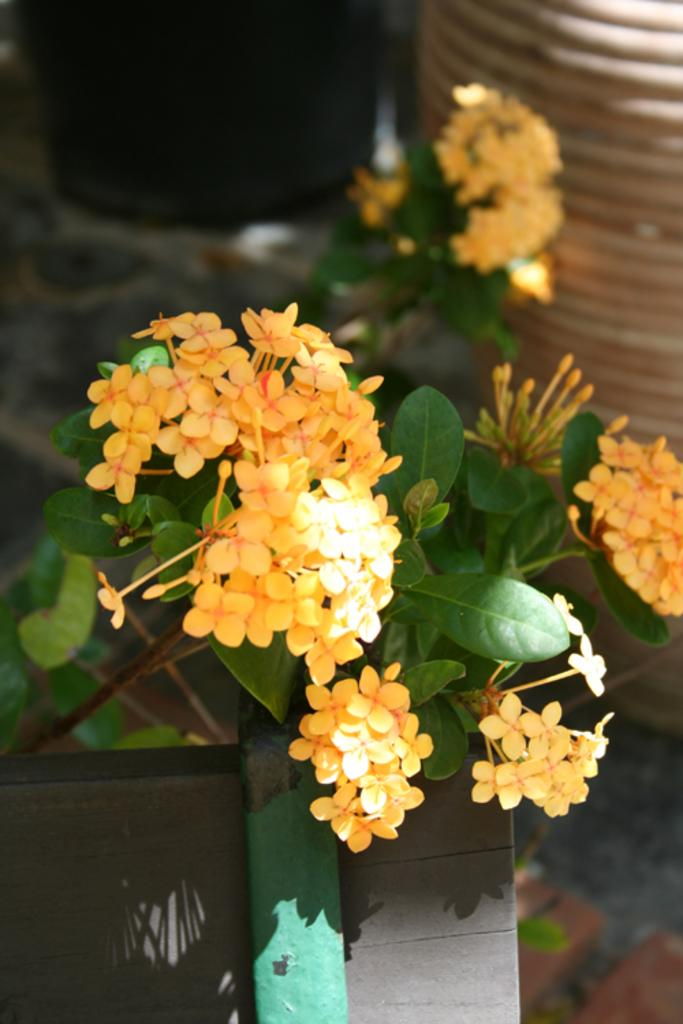What type of plant life is visible in the image? There are flowers and leaves in the image. Can you describe the objects in the background of the image? Unfortunately, the provided facts do not give any information about the objects in the background. How many types of plant life can be seen in the image? There are two types of plant life visible in the image: flowers and leaves. How does the jellyfish navigate through the water in the image? There is no jellyfish present in the image; it only contains flowers and leaves. 